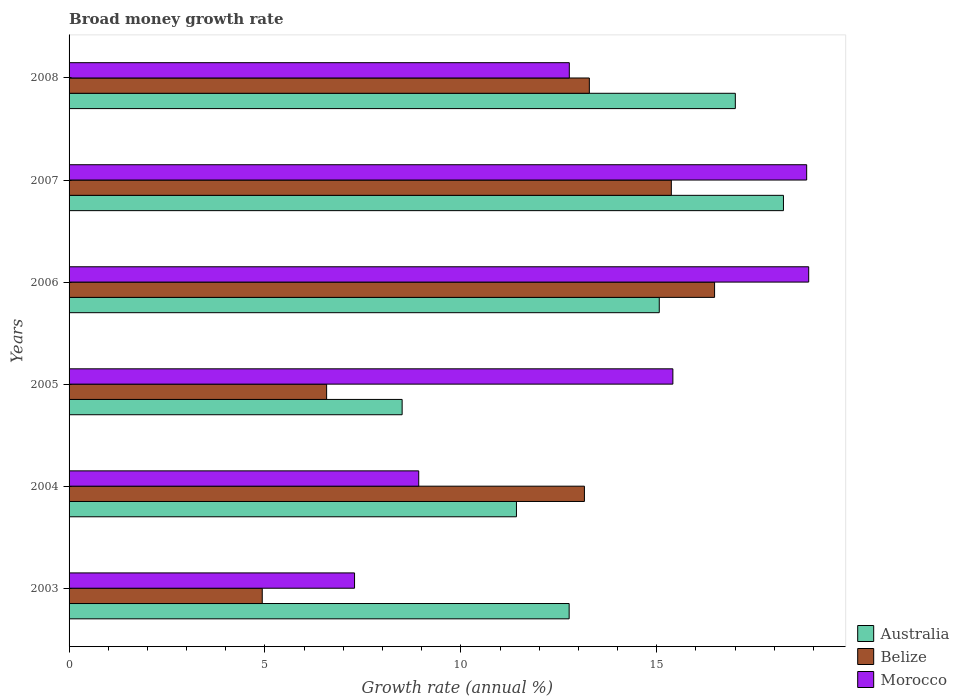How many groups of bars are there?
Your answer should be compact. 6. Are the number of bars per tick equal to the number of legend labels?
Your answer should be very brief. Yes. Are the number of bars on each tick of the Y-axis equal?
Provide a short and direct response. Yes. How many bars are there on the 3rd tick from the top?
Provide a succinct answer. 3. How many bars are there on the 4th tick from the bottom?
Ensure brevity in your answer.  3. What is the label of the 2nd group of bars from the top?
Your answer should be very brief. 2007. What is the growth rate in Australia in 2006?
Your response must be concise. 15.06. Across all years, what is the maximum growth rate in Morocco?
Provide a short and direct response. 18.88. Across all years, what is the minimum growth rate in Australia?
Offer a terse response. 8.5. In which year was the growth rate in Belize minimum?
Provide a succinct answer. 2003. What is the total growth rate in Australia in the graph?
Offer a very short reply. 82.98. What is the difference between the growth rate in Morocco in 2003 and that in 2007?
Provide a short and direct response. -11.54. What is the difference between the growth rate in Australia in 2004 and the growth rate in Belize in 2006?
Give a very brief answer. -5.06. What is the average growth rate in Australia per year?
Offer a very short reply. 13.83. In the year 2005, what is the difference between the growth rate in Australia and growth rate in Morocco?
Your answer should be compact. -6.91. What is the ratio of the growth rate in Belize in 2003 to that in 2005?
Your answer should be very brief. 0.75. What is the difference between the highest and the second highest growth rate in Australia?
Make the answer very short. 1.23. What is the difference between the highest and the lowest growth rate in Morocco?
Provide a succinct answer. 11.59. In how many years, is the growth rate in Belize greater than the average growth rate in Belize taken over all years?
Offer a terse response. 4. Is the sum of the growth rate in Australia in 2004 and 2008 greater than the maximum growth rate in Morocco across all years?
Offer a terse response. Yes. What does the 1st bar from the top in 2003 represents?
Your response must be concise. Morocco. What does the 1st bar from the bottom in 2007 represents?
Provide a short and direct response. Australia. Is it the case that in every year, the sum of the growth rate in Belize and growth rate in Australia is greater than the growth rate in Morocco?
Offer a terse response. No. How many bars are there?
Offer a very short reply. 18. What is the difference between two consecutive major ticks on the X-axis?
Give a very brief answer. 5. Are the values on the major ticks of X-axis written in scientific E-notation?
Ensure brevity in your answer.  No. Does the graph contain any zero values?
Give a very brief answer. No. Where does the legend appear in the graph?
Offer a very short reply. Bottom right. How many legend labels are there?
Your answer should be very brief. 3. How are the legend labels stacked?
Ensure brevity in your answer.  Vertical. What is the title of the graph?
Ensure brevity in your answer.  Broad money growth rate. Does "Portugal" appear as one of the legend labels in the graph?
Offer a terse response. No. What is the label or title of the X-axis?
Your answer should be very brief. Growth rate (annual %). What is the Growth rate (annual %) in Australia in 2003?
Make the answer very short. 12.76. What is the Growth rate (annual %) of Belize in 2003?
Offer a very short reply. 4.93. What is the Growth rate (annual %) in Morocco in 2003?
Your response must be concise. 7.29. What is the Growth rate (annual %) of Australia in 2004?
Make the answer very short. 11.42. What is the Growth rate (annual %) of Belize in 2004?
Offer a very short reply. 13.15. What is the Growth rate (annual %) in Morocco in 2004?
Your response must be concise. 8.92. What is the Growth rate (annual %) in Australia in 2005?
Offer a terse response. 8.5. What is the Growth rate (annual %) of Belize in 2005?
Give a very brief answer. 6.57. What is the Growth rate (annual %) of Morocco in 2005?
Provide a succinct answer. 15.41. What is the Growth rate (annual %) of Australia in 2006?
Offer a very short reply. 15.06. What is the Growth rate (annual %) in Belize in 2006?
Offer a very short reply. 16.48. What is the Growth rate (annual %) in Morocco in 2006?
Provide a succinct answer. 18.88. What is the Growth rate (annual %) in Australia in 2007?
Keep it short and to the point. 18.23. What is the Growth rate (annual %) of Belize in 2007?
Keep it short and to the point. 15.37. What is the Growth rate (annual %) in Morocco in 2007?
Your answer should be very brief. 18.83. What is the Growth rate (annual %) in Australia in 2008?
Offer a terse response. 17. What is the Growth rate (annual %) of Belize in 2008?
Give a very brief answer. 13.28. What is the Growth rate (annual %) in Morocco in 2008?
Keep it short and to the point. 12.77. Across all years, what is the maximum Growth rate (annual %) of Australia?
Keep it short and to the point. 18.23. Across all years, what is the maximum Growth rate (annual %) in Belize?
Provide a succinct answer. 16.48. Across all years, what is the maximum Growth rate (annual %) in Morocco?
Give a very brief answer. 18.88. Across all years, what is the minimum Growth rate (annual %) of Australia?
Offer a very short reply. 8.5. Across all years, what is the minimum Growth rate (annual %) in Belize?
Provide a short and direct response. 4.93. Across all years, what is the minimum Growth rate (annual %) of Morocco?
Provide a short and direct response. 7.29. What is the total Growth rate (annual %) in Australia in the graph?
Ensure brevity in your answer.  82.98. What is the total Growth rate (annual %) in Belize in the graph?
Provide a succinct answer. 69.78. What is the total Growth rate (annual %) in Morocco in the graph?
Provide a short and direct response. 82.09. What is the difference between the Growth rate (annual %) of Australia in 2003 and that in 2004?
Provide a short and direct response. 1.35. What is the difference between the Growth rate (annual %) of Belize in 2003 and that in 2004?
Make the answer very short. -8.22. What is the difference between the Growth rate (annual %) of Morocco in 2003 and that in 2004?
Ensure brevity in your answer.  -1.64. What is the difference between the Growth rate (annual %) of Australia in 2003 and that in 2005?
Provide a short and direct response. 4.26. What is the difference between the Growth rate (annual %) in Belize in 2003 and that in 2005?
Provide a short and direct response. -1.64. What is the difference between the Growth rate (annual %) of Morocco in 2003 and that in 2005?
Offer a terse response. -8.12. What is the difference between the Growth rate (annual %) in Australia in 2003 and that in 2006?
Your response must be concise. -2.3. What is the difference between the Growth rate (annual %) in Belize in 2003 and that in 2006?
Your answer should be very brief. -11.54. What is the difference between the Growth rate (annual %) in Morocco in 2003 and that in 2006?
Provide a succinct answer. -11.59. What is the difference between the Growth rate (annual %) of Australia in 2003 and that in 2007?
Ensure brevity in your answer.  -5.47. What is the difference between the Growth rate (annual %) of Belize in 2003 and that in 2007?
Your answer should be compact. -10.44. What is the difference between the Growth rate (annual %) in Morocco in 2003 and that in 2007?
Ensure brevity in your answer.  -11.54. What is the difference between the Growth rate (annual %) of Australia in 2003 and that in 2008?
Your response must be concise. -4.24. What is the difference between the Growth rate (annual %) of Belize in 2003 and that in 2008?
Ensure brevity in your answer.  -8.35. What is the difference between the Growth rate (annual %) in Morocco in 2003 and that in 2008?
Offer a very short reply. -5.48. What is the difference between the Growth rate (annual %) in Australia in 2004 and that in 2005?
Your response must be concise. 2.92. What is the difference between the Growth rate (annual %) of Belize in 2004 and that in 2005?
Your answer should be very brief. 6.58. What is the difference between the Growth rate (annual %) in Morocco in 2004 and that in 2005?
Offer a terse response. -6.49. What is the difference between the Growth rate (annual %) in Australia in 2004 and that in 2006?
Make the answer very short. -3.64. What is the difference between the Growth rate (annual %) of Belize in 2004 and that in 2006?
Your response must be concise. -3.32. What is the difference between the Growth rate (annual %) of Morocco in 2004 and that in 2006?
Provide a succinct answer. -9.95. What is the difference between the Growth rate (annual %) in Australia in 2004 and that in 2007?
Make the answer very short. -6.81. What is the difference between the Growth rate (annual %) of Belize in 2004 and that in 2007?
Provide a short and direct response. -2.22. What is the difference between the Growth rate (annual %) of Morocco in 2004 and that in 2007?
Your response must be concise. -9.9. What is the difference between the Growth rate (annual %) in Australia in 2004 and that in 2008?
Provide a short and direct response. -5.59. What is the difference between the Growth rate (annual %) of Belize in 2004 and that in 2008?
Provide a short and direct response. -0.13. What is the difference between the Growth rate (annual %) in Morocco in 2004 and that in 2008?
Your answer should be very brief. -3.84. What is the difference between the Growth rate (annual %) of Australia in 2005 and that in 2006?
Your answer should be compact. -6.56. What is the difference between the Growth rate (annual %) of Belize in 2005 and that in 2006?
Offer a very short reply. -9.9. What is the difference between the Growth rate (annual %) in Morocco in 2005 and that in 2006?
Your answer should be very brief. -3.47. What is the difference between the Growth rate (annual %) in Australia in 2005 and that in 2007?
Offer a terse response. -9.73. What is the difference between the Growth rate (annual %) of Belize in 2005 and that in 2007?
Keep it short and to the point. -8.8. What is the difference between the Growth rate (annual %) of Morocco in 2005 and that in 2007?
Give a very brief answer. -3.41. What is the difference between the Growth rate (annual %) in Australia in 2005 and that in 2008?
Offer a terse response. -8.5. What is the difference between the Growth rate (annual %) of Belize in 2005 and that in 2008?
Your response must be concise. -6.71. What is the difference between the Growth rate (annual %) of Morocco in 2005 and that in 2008?
Your answer should be compact. 2.64. What is the difference between the Growth rate (annual %) of Australia in 2006 and that in 2007?
Offer a very short reply. -3.17. What is the difference between the Growth rate (annual %) in Belize in 2006 and that in 2007?
Offer a terse response. 1.1. What is the difference between the Growth rate (annual %) in Morocco in 2006 and that in 2007?
Offer a terse response. 0.05. What is the difference between the Growth rate (annual %) in Australia in 2006 and that in 2008?
Provide a short and direct response. -1.94. What is the difference between the Growth rate (annual %) of Belize in 2006 and that in 2008?
Your answer should be very brief. 3.2. What is the difference between the Growth rate (annual %) in Morocco in 2006 and that in 2008?
Offer a terse response. 6.11. What is the difference between the Growth rate (annual %) of Australia in 2007 and that in 2008?
Provide a succinct answer. 1.23. What is the difference between the Growth rate (annual %) in Belize in 2007 and that in 2008?
Ensure brevity in your answer.  2.09. What is the difference between the Growth rate (annual %) of Morocco in 2007 and that in 2008?
Your answer should be compact. 6.06. What is the difference between the Growth rate (annual %) in Australia in 2003 and the Growth rate (annual %) in Belize in 2004?
Give a very brief answer. -0.39. What is the difference between the Growth rate (annual %) of Australia in 2003 and the Growth rate (annual %) of Morocco in 2004?
Offer a terse response. 3.84. What is the difference between the Growth rate (annual %) in Belize in 2003 and the Growth rate (annual %) in Morocco in 2004?
Provide a succinct answer. -3.99. What is the difference between the Growth rate (annual %) in Australia in 2003 and the Growth rate (annual %) in Belize in 2005?
Make the answer very short. 6.19. What is the difference between the Growth rate (annual %) of Australia in 2003 and the Growth rate (annual %) of Morocco in 2005?
Provide a succinct answer. -2.65. What is the difference between the Growth rate (annual %) of Belize in 2003 and the Growth rate (annual %) of Morocco in 2005?
Give a very brief answer. -10.48. What is the difference between the Growth rate (annual %) of Australia in 2003 and the Growth rate (annual %) of Belize in 2006?
Offer a very short reply. -3.71. What is the difference between the Growth rate (annual %) in Australia in 2003 and the Growth rate (annual %) in Morocco in 2006?
Your response must be concise. -6.11. What is the difference between the Growth rate (annual %) of Belize in 2003 and the Growth rate (annual %) of Morocco in 2006?
Offer a very short reply. -13.95. What is the difference between the Growth rate (annual %) in Australia in 2003 and the Growth rate (annual %) in Belize in 2007?
Your answer should be very brief. -2.61. What is the difference between the Growth rate (annual %) of Australia in 2003 and the Growth rate (annual %) of Morocco in 2007?
Give a very brief answer. -6.06. What is the difference between the Growth rate (annual %) in Belize in 2003 and the Growth rate (annual %) in Morocco in 2007?
Your answer should be very brief. -13.89. What is the difference between the Growth rate (annual %) in Australia in 2003 and the Growth rate (annual %) in Belize in 2008?
Ensure brevity in your answer.  -0.52. What is the difference between the Growth rate (annual %) in Australia in 2003 and the Growth rate (annual %) in Morocco in 2008?
Offer a terse response. -0. What is the difference between the Growth rate (annual %) of Belize in 2003 and the Growth rate (annual %) of Morocco in 2008?
Make the answer very short. -7.84. What is the difference between the Growth rate (annual %) in Australia in 2004 and the Growth rate (annual %) in Belize in 2005?
Give a very brief answer. 4.84. What is the difference between the Growth rate (annual %) in Australia in 2004 and the Growth rate (annual %) in Morocco in 2005?
Your answer should be very brief. -3.99. What is the difference between the Growth rate (annual %) of Belize in 2004 and the Growth rate (annual %) of Morocco in 2005?
Offer a terse response. -2.26. What is the difference between the Growth rate (annual %) in Australia in 2004 and the Growth rate (annual %) in Belize in 2006?
Provide a short and direct response. -5.06. What is the difference between the Growth rate (annual %) in Australia in 2004 and the Growth rate (annual %) in Morocco in 2006?
Give a very brief answer. -7.46. What is the difference between the Growth rate (annual %) of Belize in 2004 and the Growth rate (annual %) of Morocco in 2006?
Give a very brief answer. -5.72. What is the difference between the Growth rate (annual %) in Australia in 2004 and the Growth rate (annual %) in Belize in 2007?
Offer a very short reply. -3.95. What is the difference between the Growth rate (annual %) in Australia in 2004 and the Growth rate (annual %) in Morocco in 2007?
Offer a terse response. -7.41. What is the difference between the Growth rate (annual %) of Belize in 2004 and the Growth rate (annual %) of Morocco in 2007?
Offer a terse response. -5.67. What is the difference between the Growth rate (annual %) of Australia in 2004 and the Growth rate (annual %) of Belize in 2008?
Your answer should be compact. -1.86. What is the difference between the Growth rate (annual %) in Australia in 2004 and the Growth rate (annual %) in Morocco in 2008?
Your answer should be very brief. -1.35. What is the difference between the Growth rate (annual %) of Belize in 2004 and the Growth rate (annual %) of Morocco in 2008?
Offer a terse response. 0.39. What is the difference between the Growth rate (annual %) of Australia in 2005 and the Growth rate (annual %) of Belize in 2006?
Offer a terse response. -7.97. What is the difference between the Growth rate (annual %) in Australia in 2005 and the Growth rate (annual %) in Morocco in 2006?
Make the answer very short. -10.38. What is the difference between the Growth rate (annual %) in Belize in 2005 and the Growth rate (annual %) in Morocco in 2006?
Offer a very short reply. -12.3. What is the difference between the Growth rate (annual %) in Australia in 2005 and the Growth rate (annual %) in Belize in 2007?
Give a very brief answer. -6.87. What is the difference between the Growth rate (annual %) of Australia in 2005 and the Growth rate (annual %) of Morocco in 2007?
Give a very brief answer. -10.32. What is the difference between the Growth rate (annual %) in Belize in 2005 and the Growth rate (annual %) in Morocco in 2007?
Your answer should be compact. -12.25. What is the difference between the Growth rate (annual %) in Australia in 2005 and the Growth rate (annual %) in Belize in 2008?
Offer a very short reply. -4.78. What is the difference between the Growth rate (annual %) in Australia in 2005 and the Growth rate (annual %) in Morocco in 2008?
Your response must be concise. -4.27. What is the difference between the Growth rate (annual %) of Belize in 2005 and the Growth rate (annual %) of Morocco in 2008?
Provide a succinct answer. -6.19. What is the difference between the Growth rate (annual %) of Australia in 2006 and the Growth rate (annual %) of Belize in 2007?
Your answer should be compact. -0.31. What is the difference between the Growth rate (annual %) in Australia in 2006 and the Growth rate (annual %) in Morocco in 2007?
Provide a succinct answer. -3.76. What is the difference between the Growth rate (annual %) of Belize in 2006 and the Growth rate (annual %) of Morocco in 2007?
Provide a succinct answer. -2.35. What is the difference between the Growth rate (annual %) in Australia in 2006 and the Growth rate (annual %) in Belize in 2008?
Make the answer very short. 1.78. What is the difference between the Growth rate (annual %) in Australia in 2006 and the Growth rate (annual %) in Morocco in 2008?
Your response must be concise. 2.3. What is the difference between the Growth rate (annual %) of Belize in 2006 and the Growth rate (annual %) of Morocco in 2008?
Provide a short and direct response. 3.71. What is the difference between the Growth rate (annual %) of Australia in 2007 and the Growth rate (annual %) of Belize in 2008?
Provide a short and direct response. 4.95. What is the difference between the Growth rate (annual %) of Australia in 2007 and the Growth rate (annual %) of Morocco in 2008?
Your answer should be very brief. 5.47. What is the difference between the Growth rate (annual %) in Belize in 2007 and the Growth rate (annual %) in Morocco in 2008?
Make the answer very short. 2.6. What is the average Growth rate (annual %) in Australia per year?
Ensure brevity in your answer.  13.83. What is the average Growth rate (annual %) in Belize per year?
Your response must be concise. 11.63. What is the average Growth rate (annual %) of Morocco per year?
Make the answer very short. 13.68. In the year 2003, what is the difference between the Growth rate (annual %) in Australia and Growth rate (annual %) in Belize?
Offer a very short reply. 7.83. In the year 2003, what is the difference between the Growth rate (annual %) of Australia and Growth rate (annual %) of Morocco?
Ensure brevity in your answer.  5.48. In the year 2003, what is the difference between the Growth rate (annual %) of Belize and Growth rate (annual %) of Morocco?
Provide a succinct answer. -2.36. In the year 2004, what is the difference between the Growth rate (annual %) in Australia and Growth rate (annual %) in Belize?
Make the answer very short. -1.73. In the year 2004, what is the difference between the Growth rate (annual %) of Australia and Growth rate (annual %) of Morocco?
Give a very brief answer. 2.49. In the year 2004, what is the difference between the Growth rate (annual %) in Belize and Growth rate (annual %) in Morocco?
Provide a succinct answer. 4.23. In the year 2005, what is the difference between the Growth rate (annual %) of Australia and Growth rate (annual %) of Belize?
Make the answer very short. 1.93. In the year 2005, what is the difference between the Growth rate (annual %) of Australia and Growth rate (annual %) of Morocco?
Make the answer very short. -6.91. In the year 2005, what is the difference between the Growth rate (annual %) of Belize and Growth rate (annual %) of Morocco?
Your answer should be very brief. -8.84. In the year 2006, what is the difference between the Growth rate (annual %) of Australia and Growth rate (annual %) of Belize?
Provide a short and direct response. -1.41. In the year 2006, what is the difference between the Growth rate (annual %) in Australia and Growth rate (annual %) in Morocco?
Give a very brief answer. -3.81. In the year 2006, what is the difference between the Growth rate (annual %) of Belize and Growth rate (annual %) of Morocco?
Your response must be concise. -2.4. In the year 2007, what is the difference between the Growth rate (annual %) of Australia and Growth rate (annual %) of Belize?
Your response must be concise. 2.86. In the year 2007, what is the difference between the Growth rate (annual %) of Australia and Growth rate (annual %) of Morocco?
Keep it short and to the point. -0.59. In the year 2007, what is the difference between the Growth rate (annual %) in Belize and Growth rate (annual %) in Morocco?
Ensure brevity in your answer.  -3.45. In the year 2008, what is the difference between the Growth rate (annual %) in Australia and Growth rate (annual %) in Belize?
Provide a succinct answer. 3.73. In the year 2008, what is the difference between the Growth rate (annual %) of Australia and Growth rate (annual %) of Morocco?
Make the answer very short. 4.24. In the year 2008, what is the difference between the Growth rate (annual %) in Belize and Growth rate (annual %) in Morocco?
Keep it short and to the point. 0.51. What is the ratio of the Growth rate (annual %) in Australia in 2003 to that in 2004?
Give a very brief answer. 1.12. What is the ratio of the Growth rate (annual %) in Belize in 2003 to that in 2004?
Keep it short and to the point. 0.37. What is the ratio of the Growth rate (annual %) in Morocco in 2003 to that in 2004?
Your response must be concise. 0.82. What is the ratio of the Growth rate (annual %) of Australia in 2003 to that in 2005?
Make the answer very short. 1.5. What is the ratio of the Growth rate (annual %) in Belize in 2003 to that in 2005?
Keep it short and to the point. 0.75. What is the ratio of the Growth rate (annual %) of Morocco in 2003 to that in 2005?
Your answer should be very brief. 0.47. What is the ratio of the Growth rate (annual %) in Australia in 2003 to that in 2006?
Keep it short and to the point. 0.85. What is the ratio of the Growth rate (annual %) of Belize in 2003 to that in 2006?
Keep it short and to the point. 0.3. What is the ratio of the Growth rate (annual %) of Morocco in 2003 to that in 2006?
Your answer should be very brief. 0.39. What is the ratio of the Growth rate (annual %) of Australia in 2003 to that in 2007?
Ensure brevity in your answer.  0.7. What is the ratio of the Growth rate (annual %) of Belize in 2003 to that in 2007?
Provide a succinct answer. 0.32. What is the ratio of the Growth rate (annual %) in Morocco in 2003 to that in 2007?
Your response must be concise. 0.39. What is the ratio of the Growth rate (annual %) in Australia in 2003 to that in 2008?
Keep it short and to the point. 0.75. What is the ratio of the Growth rate (annual %) of Belize in 2003 to that in 2008?
Your response must be concise. 0.37. What is the ratio of the Growth rate (annual %) in Morocco in 2003 to that in 2008?
Make the answer very short. 0.57. What is the ratio of the Growth rate (annual %) of Australia in 2004 to that in 2005?
Provide a succinct answer. 1.34. What is the ratio of the Growth rate (annual %) in Belize in 2004 to that in 2005?
Keep it short and to the point. 2. What is the ratio of the Growth rate (annual %) of Morocco in 2004 to that in 2005?
Your response must be concise. 0.58. What is the ratio of the Growth rate (annual %) of Australia in 2004 to that in 2006?
Give a very brief answer. 0.76. What is the ratio of the Growth rate (annual %) in Belize in 2004 to that in 2006?
Your answer should be very brief. 0.8. What is the ratio of the Growth rate (annual %) of Morocco in 2004 to that in 2006?
Provide a short and direct response. 0.47. What is the ratio of the Growth rate (annual %) in Australia in 2004 to that in 2007?
Give a very brief answer. 0.63. What is the ratio of the Growth rate (annual %) of Belize in 2004 to that in 2007?
Offer a very short reply. 0.86. What is the ratio of the Growth rate (annual %) in Morocco in 2004 to that in 2007?
Ensure brevity in your answer.  0.47. What is the ratio of the Growth rate (annual %) of Australia in 2004 to that in 2008?
Provide a succinct answer. 0.67. What is the ratio of the Growth rate (annual %) in Morocco in 2004 to that in 2008?
Your answer should be very brief. 0.7. What is the ratio of the Growth rate (annual %) of Australia in 2005 to that in 2006?
Your response must be concise. 0.56. What is the ratio of the Growth rate (annual %) of Belize in 2005 to that in 2006?
Ensure brevity in your answer.  0.4. What is the ratio of the Growth rate (annual %) in Morocco in 2005 to that in 2006?
Offer a terse response. 0.82. What is the ratio of the Growth rate (annual %) in Australia in 2005 to that in 2007?
Offer a very short reply. 0.47. What is the ratio of the Growth rate (annual %) in Belize in 2005 to that in 2007?
Give a very brief answer. 0.43. What is the ratio of the Growth rate (annual %) of Morocco in 2005 to that in 2007?
Ensure brevity in your answer.  0.82. What is the ratio of the Growth rate (annual %) in Australia in 2005 to that in 2008?
Your answer should be very brief. 0.5. What is the ratio of the Growth rate (annual %) of Belize in 2005 to that in 2008?
Make the answer very short. 0.49. What is the ratio of the Growth rate (annual %) of Morocco in 2005 to that in 2008?
Provide a short and direct response. 1.21. What is the ratio of the Growth rate (annual %) of Australia in 2006 to that in 2007?
Give a very brief answer. 0.83. What is the ratio of the Growth rate (annual %) in Belize in 2006 to that in 2007?
Your answer should be compact. 1.07. What is the ratio of the Growth rate (annual %) of Australia in 2006 to that in 2008?
Offer a terse response. 0.89. What is the ratio of the Growth rate (annual %) in Belize in 2006 to that in 2008?
Keep it short and to the point. 1.24. What is the ratio of the Growth rate (annual %) in Morocco in 2006 to that in 2008?
Offer a terse response. 1.48. What is the ratio of the Growth rate (annual %) in Australia in 2007 to that in 2008?
Offer a terse response. 1.07. What is the ratio of the Growth rate (annual %) in Belize in 2007 to that in 2008?
Keep it short and to the point. 1.16. What is the ratio of the Growth rate (annual %) of Morocco in 2007 to that in 2008?
Provide a short and direct response. 1.47. What is the difference between the highest and the second highest Growth rate (annual %) of Australia?
Your answer should be very brief. 1.23. What is the difference between the highest and the second highest Growth rate (annual %) of Belize?
Provide a succinct answer. 1.1. What is the difference between the highest and the second highest Growth rate (annual %) of Morocco?
Your answer should be compact. 0.05. What is the difference between the highest and the lowest Growth rate (annual %) of Australia?
Give a very brief answer. 9.73. What is the difference between the highest and the lowest Growth rate (annual %) in Belize?
Provide a short and direct response. 11.54. What is the difference between the highest and the lowest Growth rate (annual %) of Morocco?
Provide a short and direct response. 11.59. 